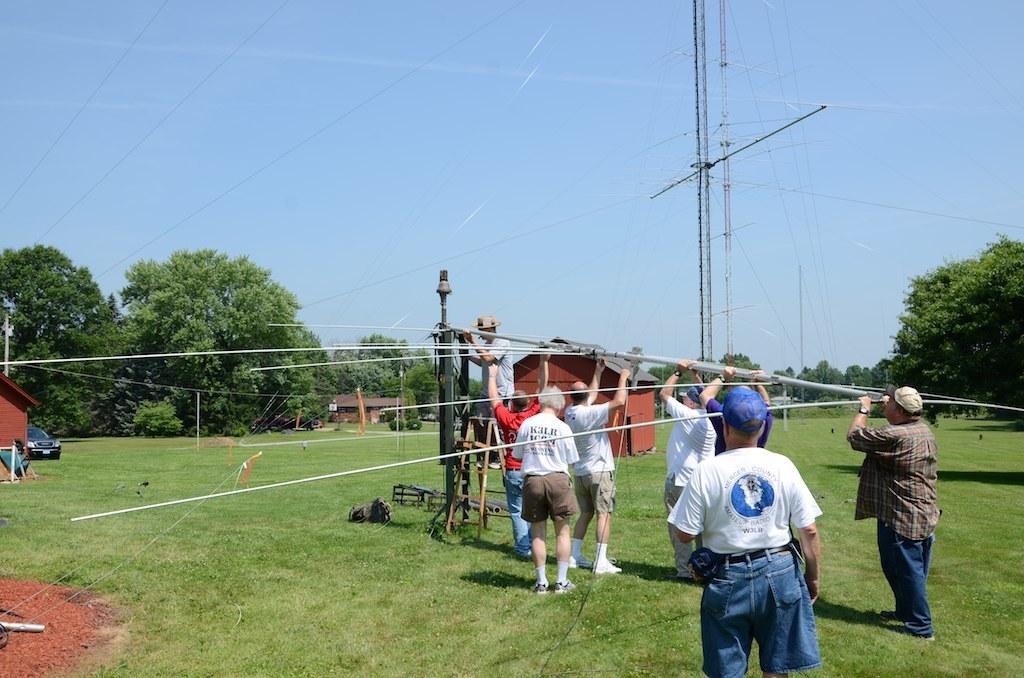How would you summarize this image in a sentence or two? In this image few persons are standing and holding the rods. A person is standing on the ladder and holding a pole. A person wearing a white shirt is having a cap. A person wearing a cap is standing on the grass land. Left side there is a house beside there is a car on the grassland. Middle of image there is a house and few plants are on the grassland. Background there are few trees. Top of image there is sky. There are few poles connected with wires. 